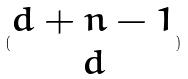Convert formula to latex. <formula><loc_0><loc_0><loc_500><loc_500>( \begin{matrix} d + n - 1 \\ d \end{matrix} )</formula> 